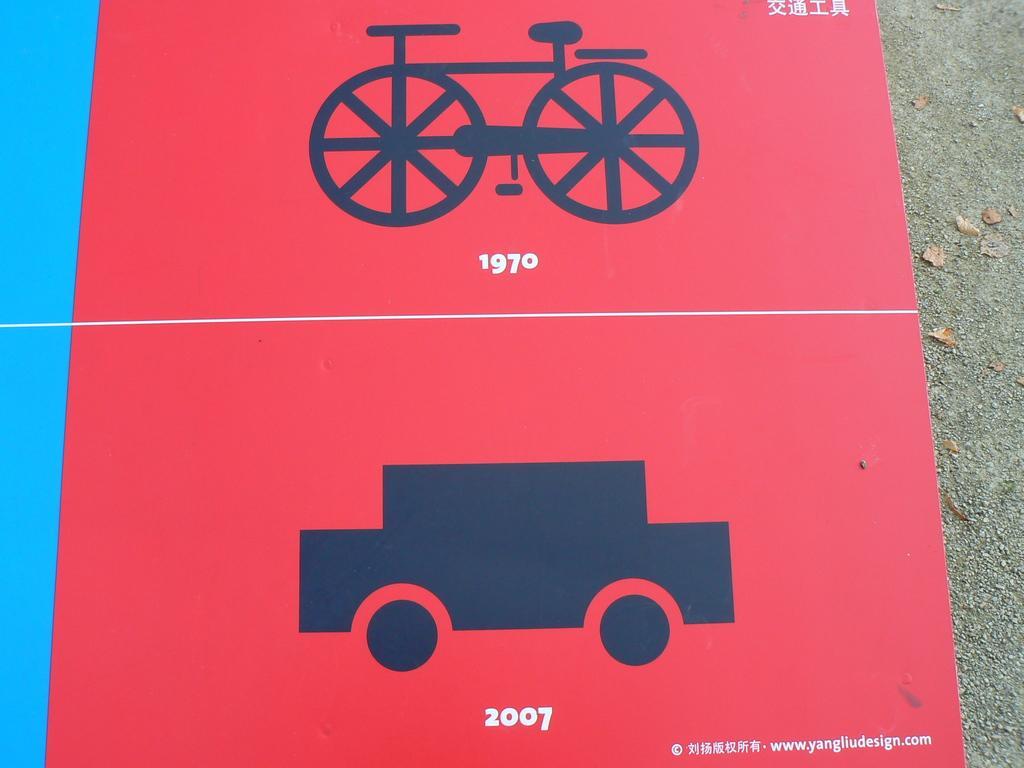Please provide a concise description of this image. This is a poster. On this poster we can see picture of a bicycle and a car. 